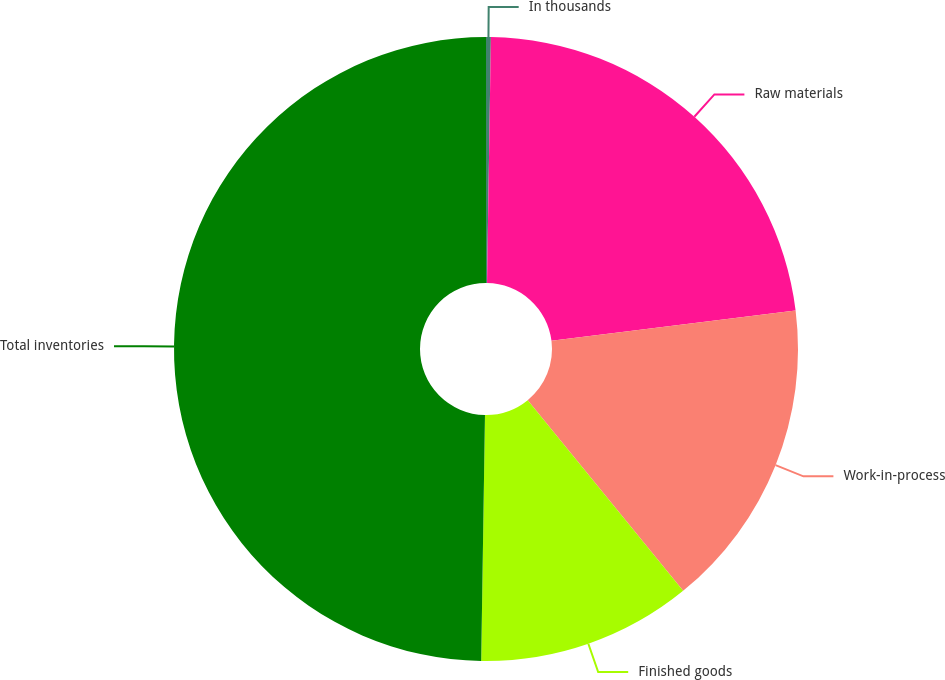Convert chart to OTSL. <chart><loc_0><loc_0><loc_500><loc_500><pie_chart><fcel>In thousands<fcel>Raw materials<fcel>Work-in-process<fcel>Finished goods<fcel>Total inventories<nl><fcel>0.25%<fcel>22.78%<fcel>16.09%<fcel>11.13%<fcel>49.76%<nl></chart> 